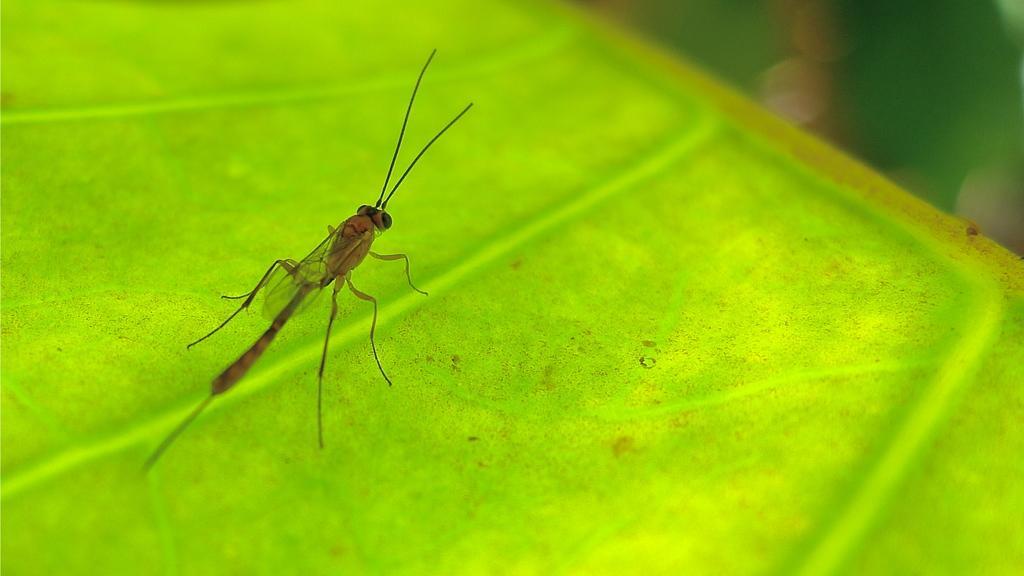Could you give a brief overview of what you see in this image? In this image we can see an insect on the green surface. On the right side top of the image there is a blur background. 